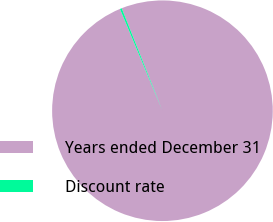Convert chart. <chart><loc_0><loc_0><loc_500><loc_500><pie_chart><fcel>Years ended December 31<fcel>Discount rate<nl><fcel>99.73%<fcel>0.27%<nl></chart> 